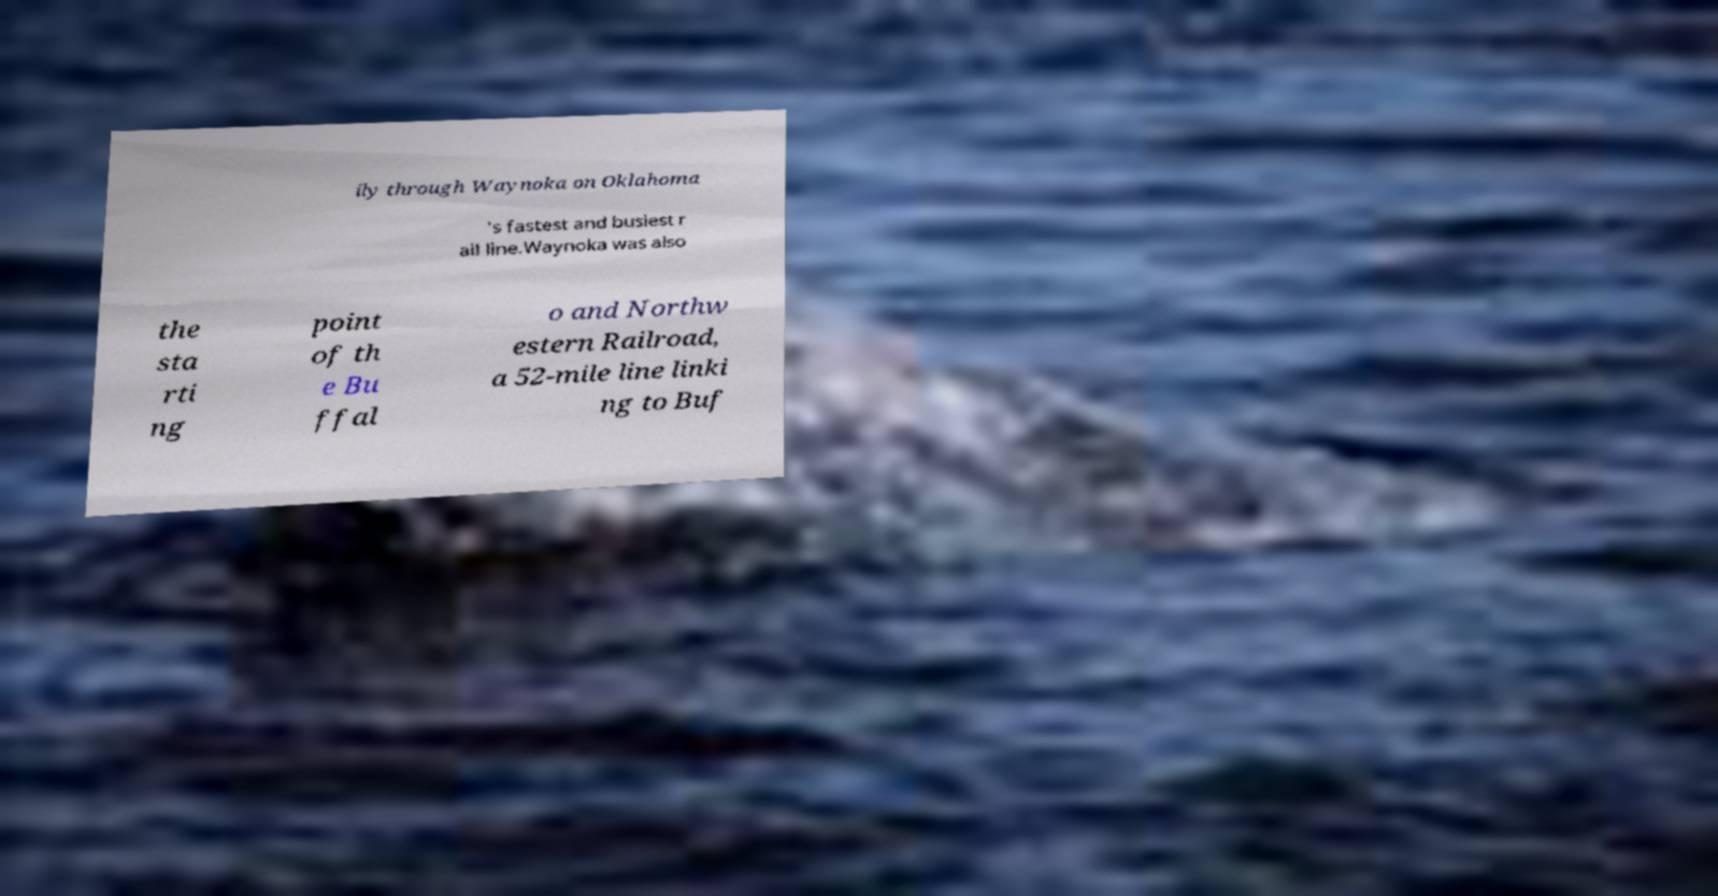Can you accurately transcribe the text from the provided image for me? ily through Waynoka on Oklahoma 's fastest and busiest r ail line.Waynoka was also the sta rti ng point of th e Bu ffal o and Northw estern Railroad, a 52-mile line linki ng to Buf 